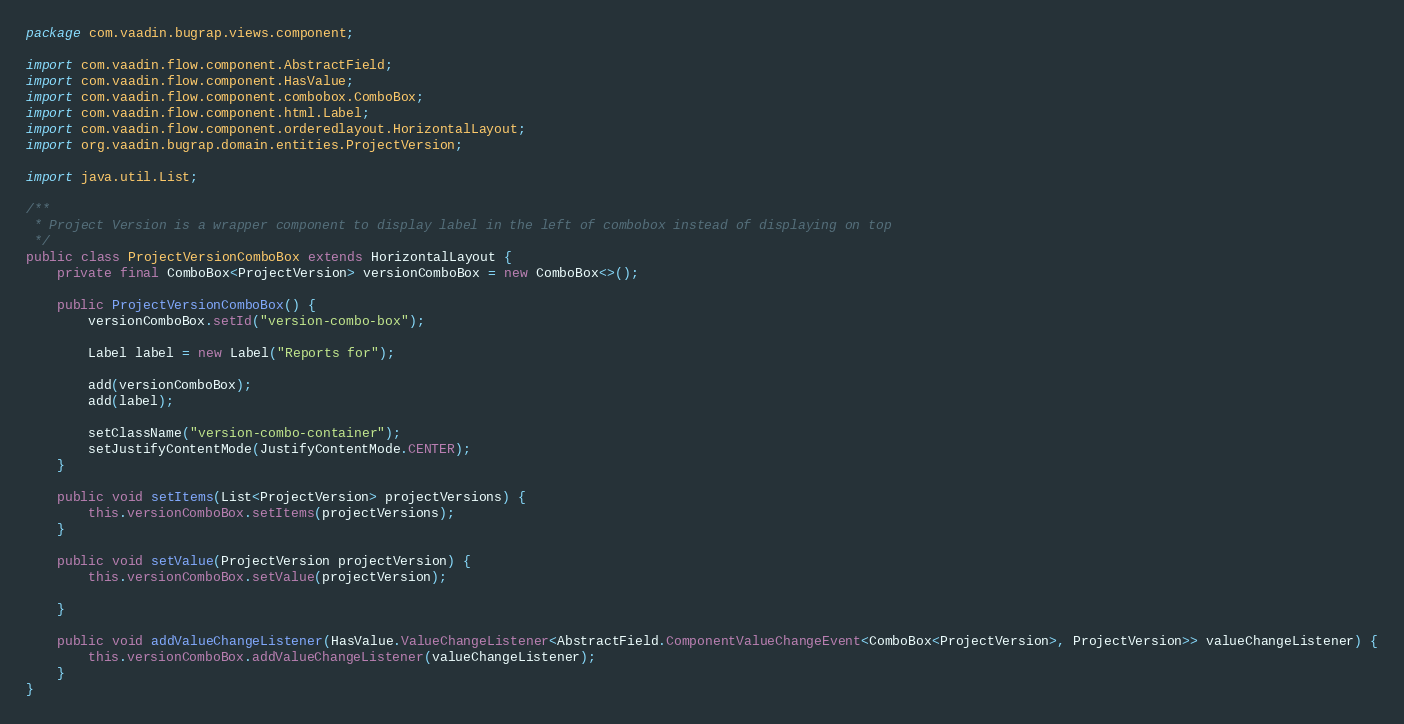Convert code to text. <code><loc_0><loc_0><loc_500><loc_500><_Java_>package com.vaadin.bugrap.views.component;

import com.vaadin.flow.component.AbstractField;
import com.vaadin.flow.component.HasValue;
import com.vaadin.flow.component.combobox.ComboBox;
import com.vaadin.flow.component.html.Label;
import com.vaadin.flow.component.orderedlayout.HorizontalLayout;
import org.vaadin.bugrap.domain.entities.ProjectVersion;

import java.util.List;

/**
 * Project Version is a wrapper component to display label in the left of combobox instead of displaying on top
 */
public class ProjectVersionComboBox extends HorizontalLayout {
    private final ComboBox<ProjectVersion> versionComboBox = new ComboBox<>();

    public ProjectVersionComboBox() {
        versionComboBox.setId("version-combo-box");

        Label label = new Label("Reports for");

        add(versionComboBox);
        add(label);

        setClassName("version-combo-container");
        setJustifyContentMode(JustifyContentMode.CENTER);
    }

    public void setItems(List<ProjectVersion> projectVersions) {
        this.versionComboBox.setItems(projectVersions);
    }

    public void setValue(ProjectVersion projectVersion) {
        this.versionComboBox.setValue(projectVersion);

    }

    public void addValueChangeListener(HasValue.ValueChangeListener<AbstractField.ComponentValueChangeEvent<ComboBox<ProjectVersion>, ProjectVersion>> valueChangeListener) {
        this.versionComboBox.addValueChangeListener(valueChangeListener);
    }
}
</code> 